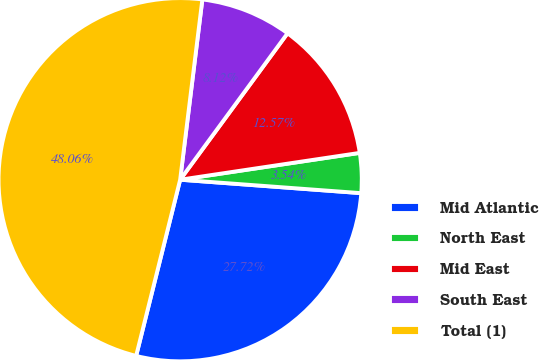Convert chart to OTSL. <chart><loc_0><loc_0><loc_500><loc_500><pie_chart><fcel>Mid Atlantic<fcel>North East<fcel>Mid East<fcel>South East<fcel>Total (1)<nl><fcel>27.72%<fcel>3.54%<fcel>12.57%<fcel>8.12%<fcel>48.06%<nl></chart> 